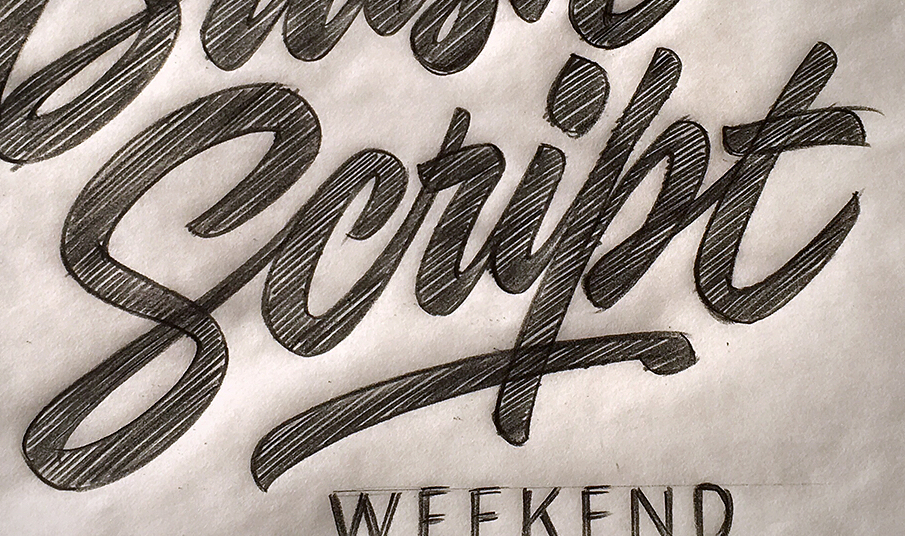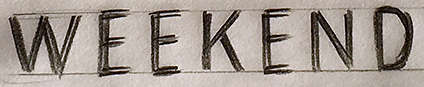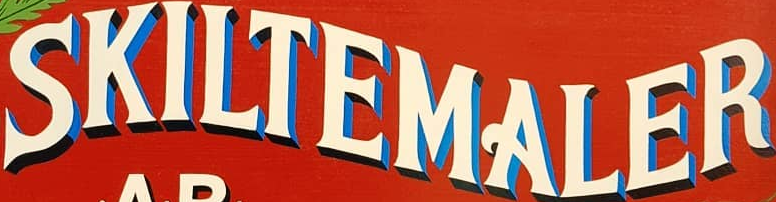Read the text from these images in sequence, separated by a semicolon. Script; WEEKEND; SKILTEMALER 